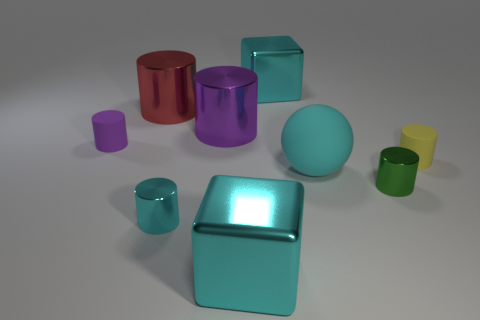Subtract 3 cylinders. How many cylinders are left? 3 Subtract all cyan metal cylinders. How many cylinders are left? 5 Subtract all purple cylinders. How many cylinders are left? 4 Subtract all yellow cylinders. Subtract all green blocks. How many cylinders are left? 5 Add 1 small blue shiny spheres. How many objects exist? 10 Subtract all balls. How many objects are left? 8 Subtract all green spheres. Subtract all rubber things. How many objects are left? 6 Add 6 tiny green objects. How many tiny green objects are left? 7 Add 4 purple blocks. How many purple blocks exist? 4 Subtract 1 cyan spheres. How many objects are left? 8 